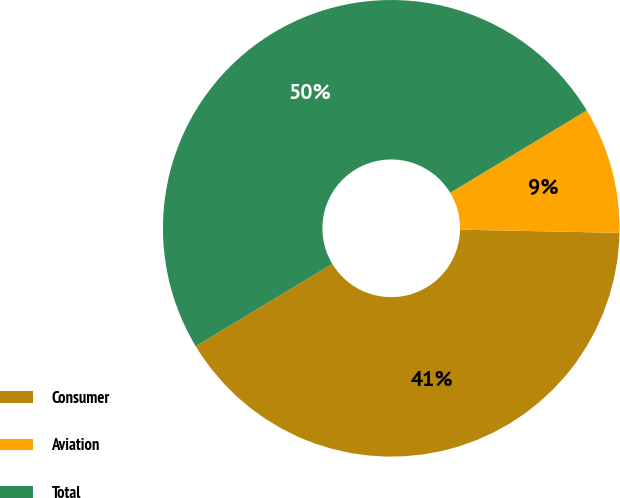<chart> <loc_0><loc_0><loc_500><loc_500><pie_chart><fcel>Consumer<fcel>Aviation<fcel>Total<nl><fcel>41.05%<fcel>8.95%<fcel>50.0%<nl></chart> 